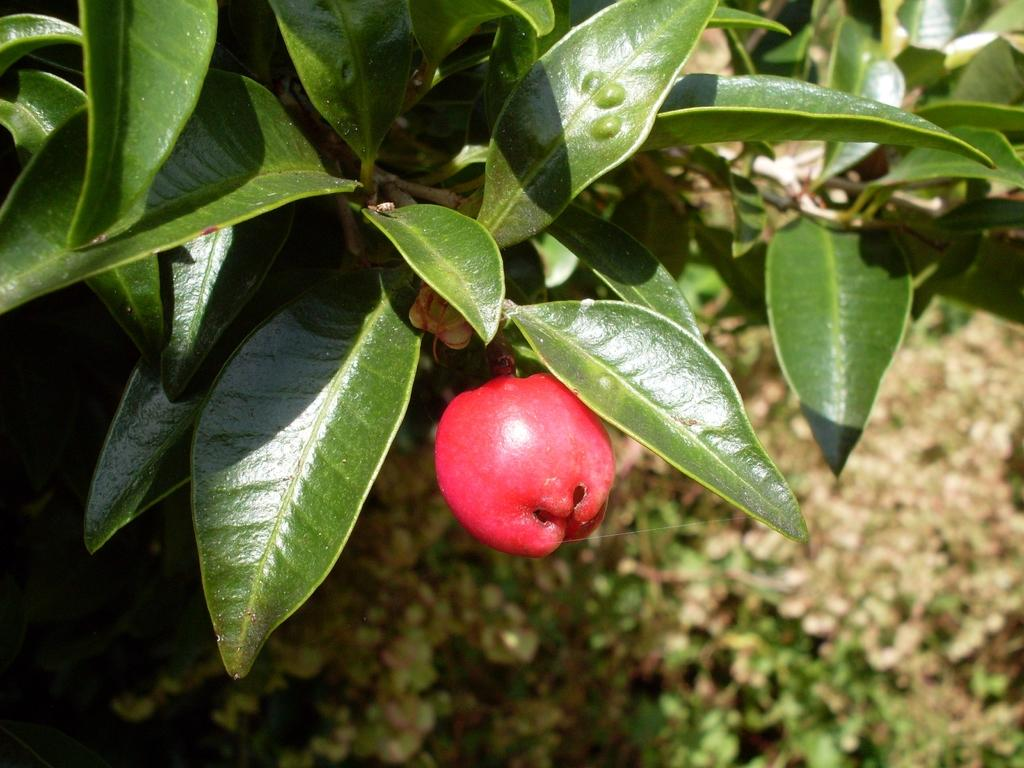What type of plant is visible in the image? There is a fruit plant in the image. Can you describe the background of the image? The background of the image is blurred. How many jars of fruit are visible in the image? There are no jars of fruit present in the image; it features a fruit plant. What type of shoes can be seen on the fruit plant in the image? There are no shoes present in the image, as it features a fruit plant and not a person wearing shoes. 